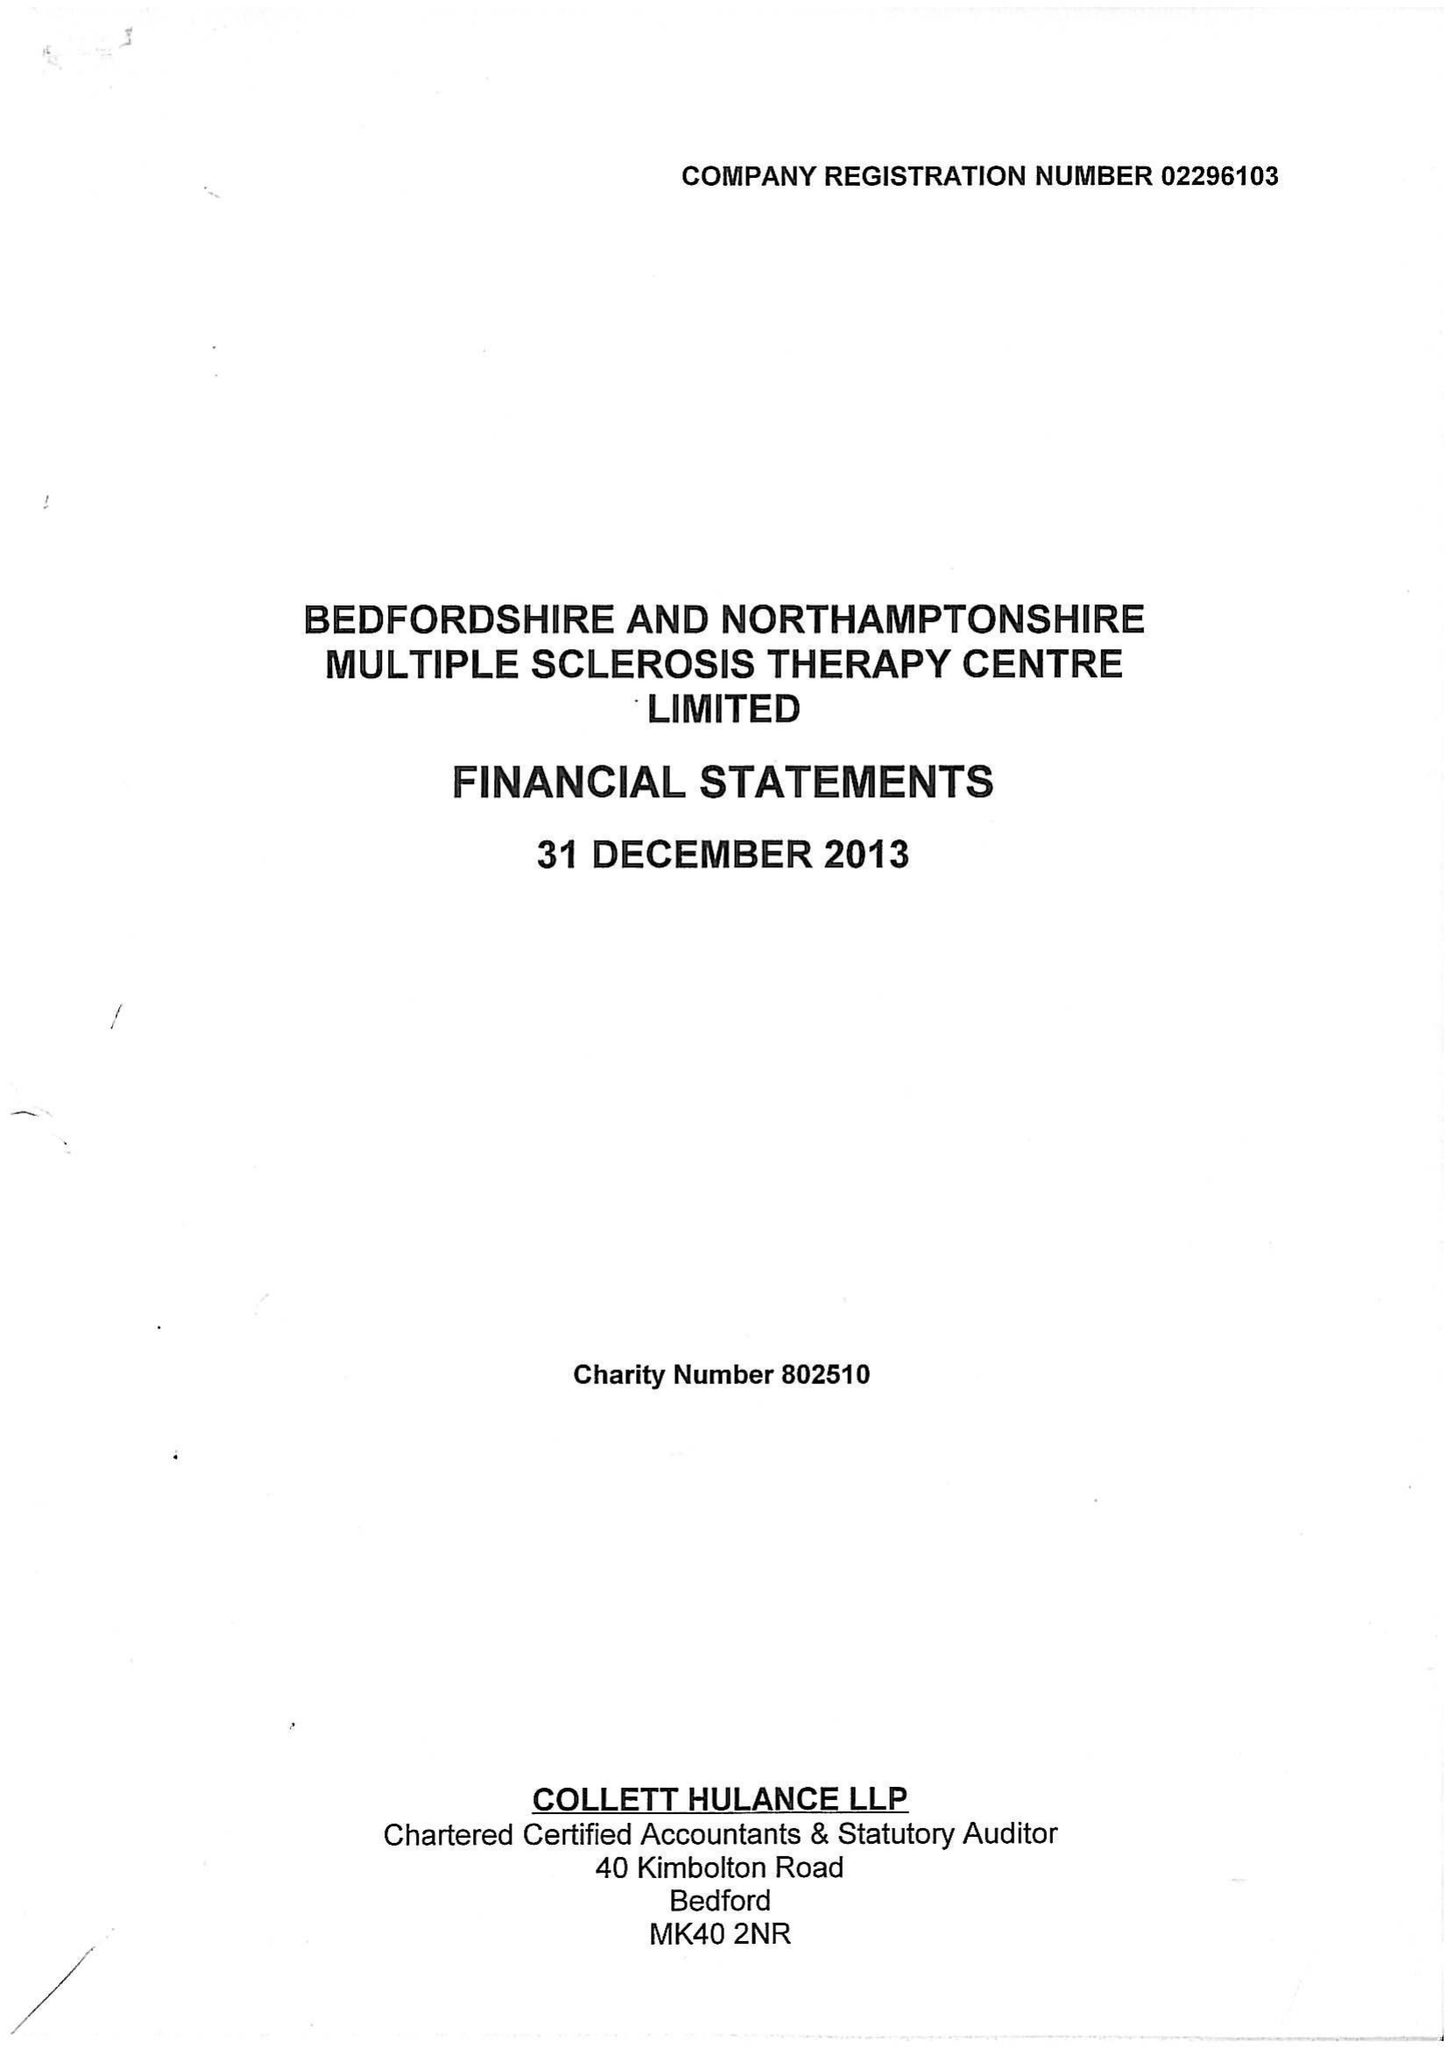What is the value for the address__post_town?
Answer the question using a single word or phrase. BEDFORD 